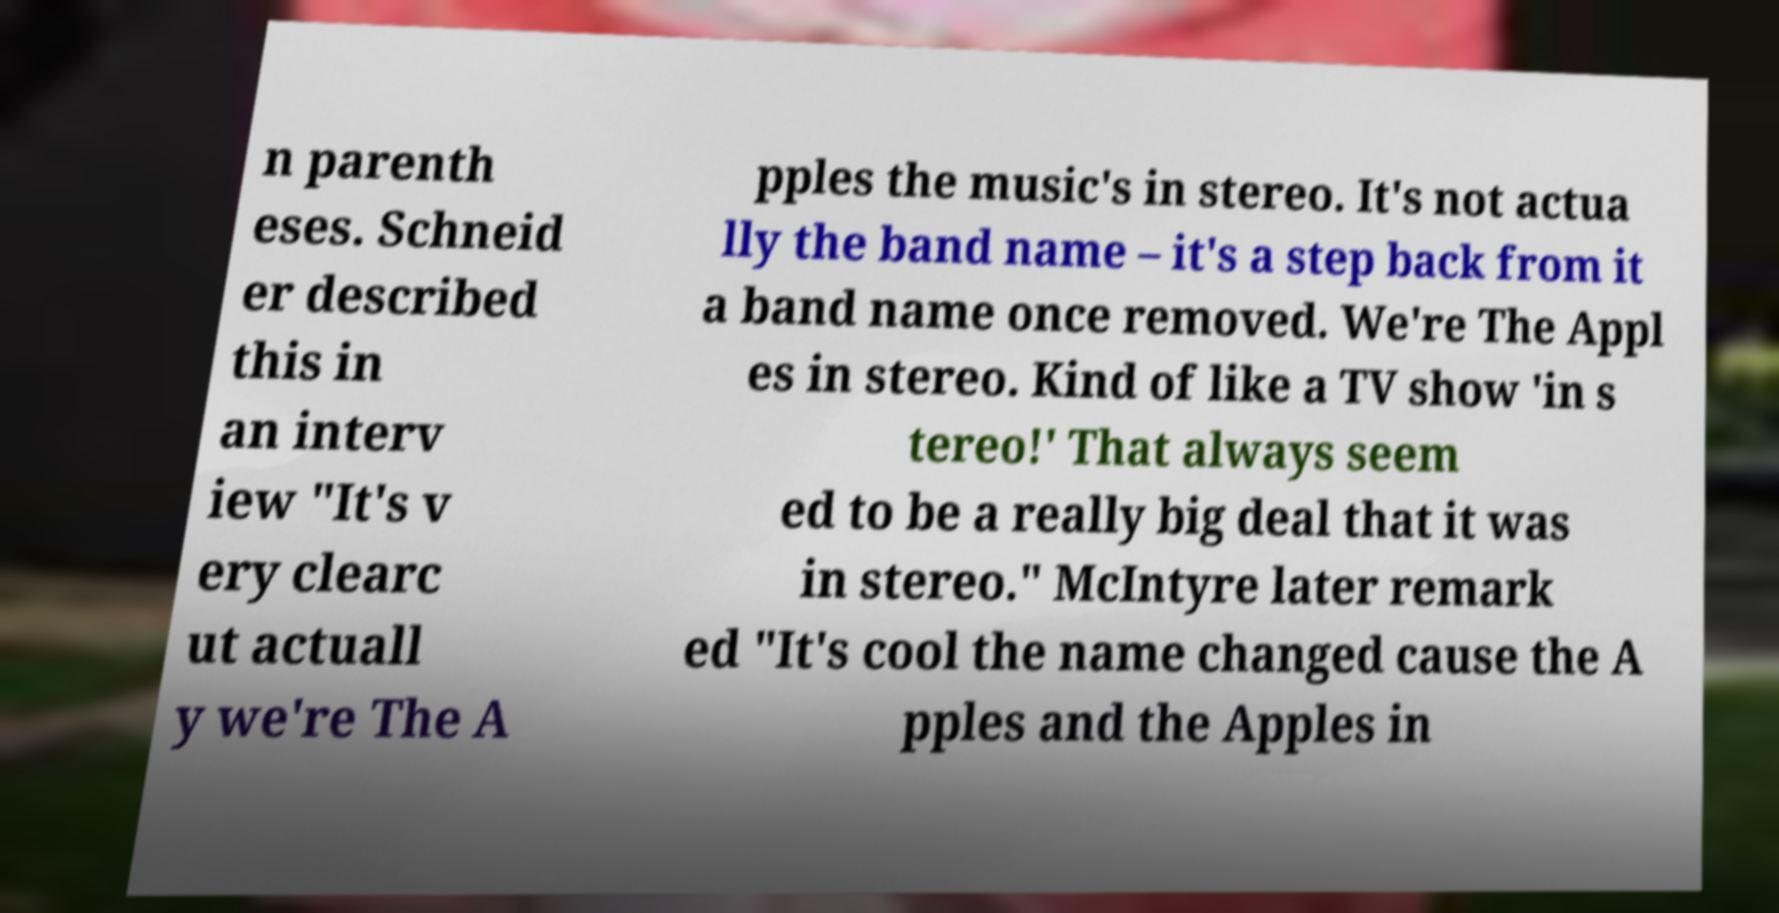Please identify and transcribe the text found in this image. n parenth eses. Schneid er described this in an interv iew "It's v ery clearc ut actuall y we're The A pples the music's in stereo. It's not actua lly the band name – it's a step back from it a band name once removed. We're The Appl es in stereo. Kind of like a TV show 'in s tereo!' That always seem ed to be a really big deal that it was in stereo." McIntyre later remark ed "It's cool the name changed cause the A pples and the Apples in 